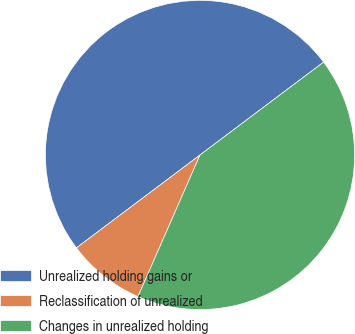Convert chart to OTSL. <chart><loc_0><loc_0><loc_500><loc_500><pie_chart><fcel>Unrealized holding gains or<fcel>Reclassification of unrealized<fcel>Changes in unrealized holding<nl><fcel>50.0%<fcel>8.17%<fcel>41.83%<nl></chart> 